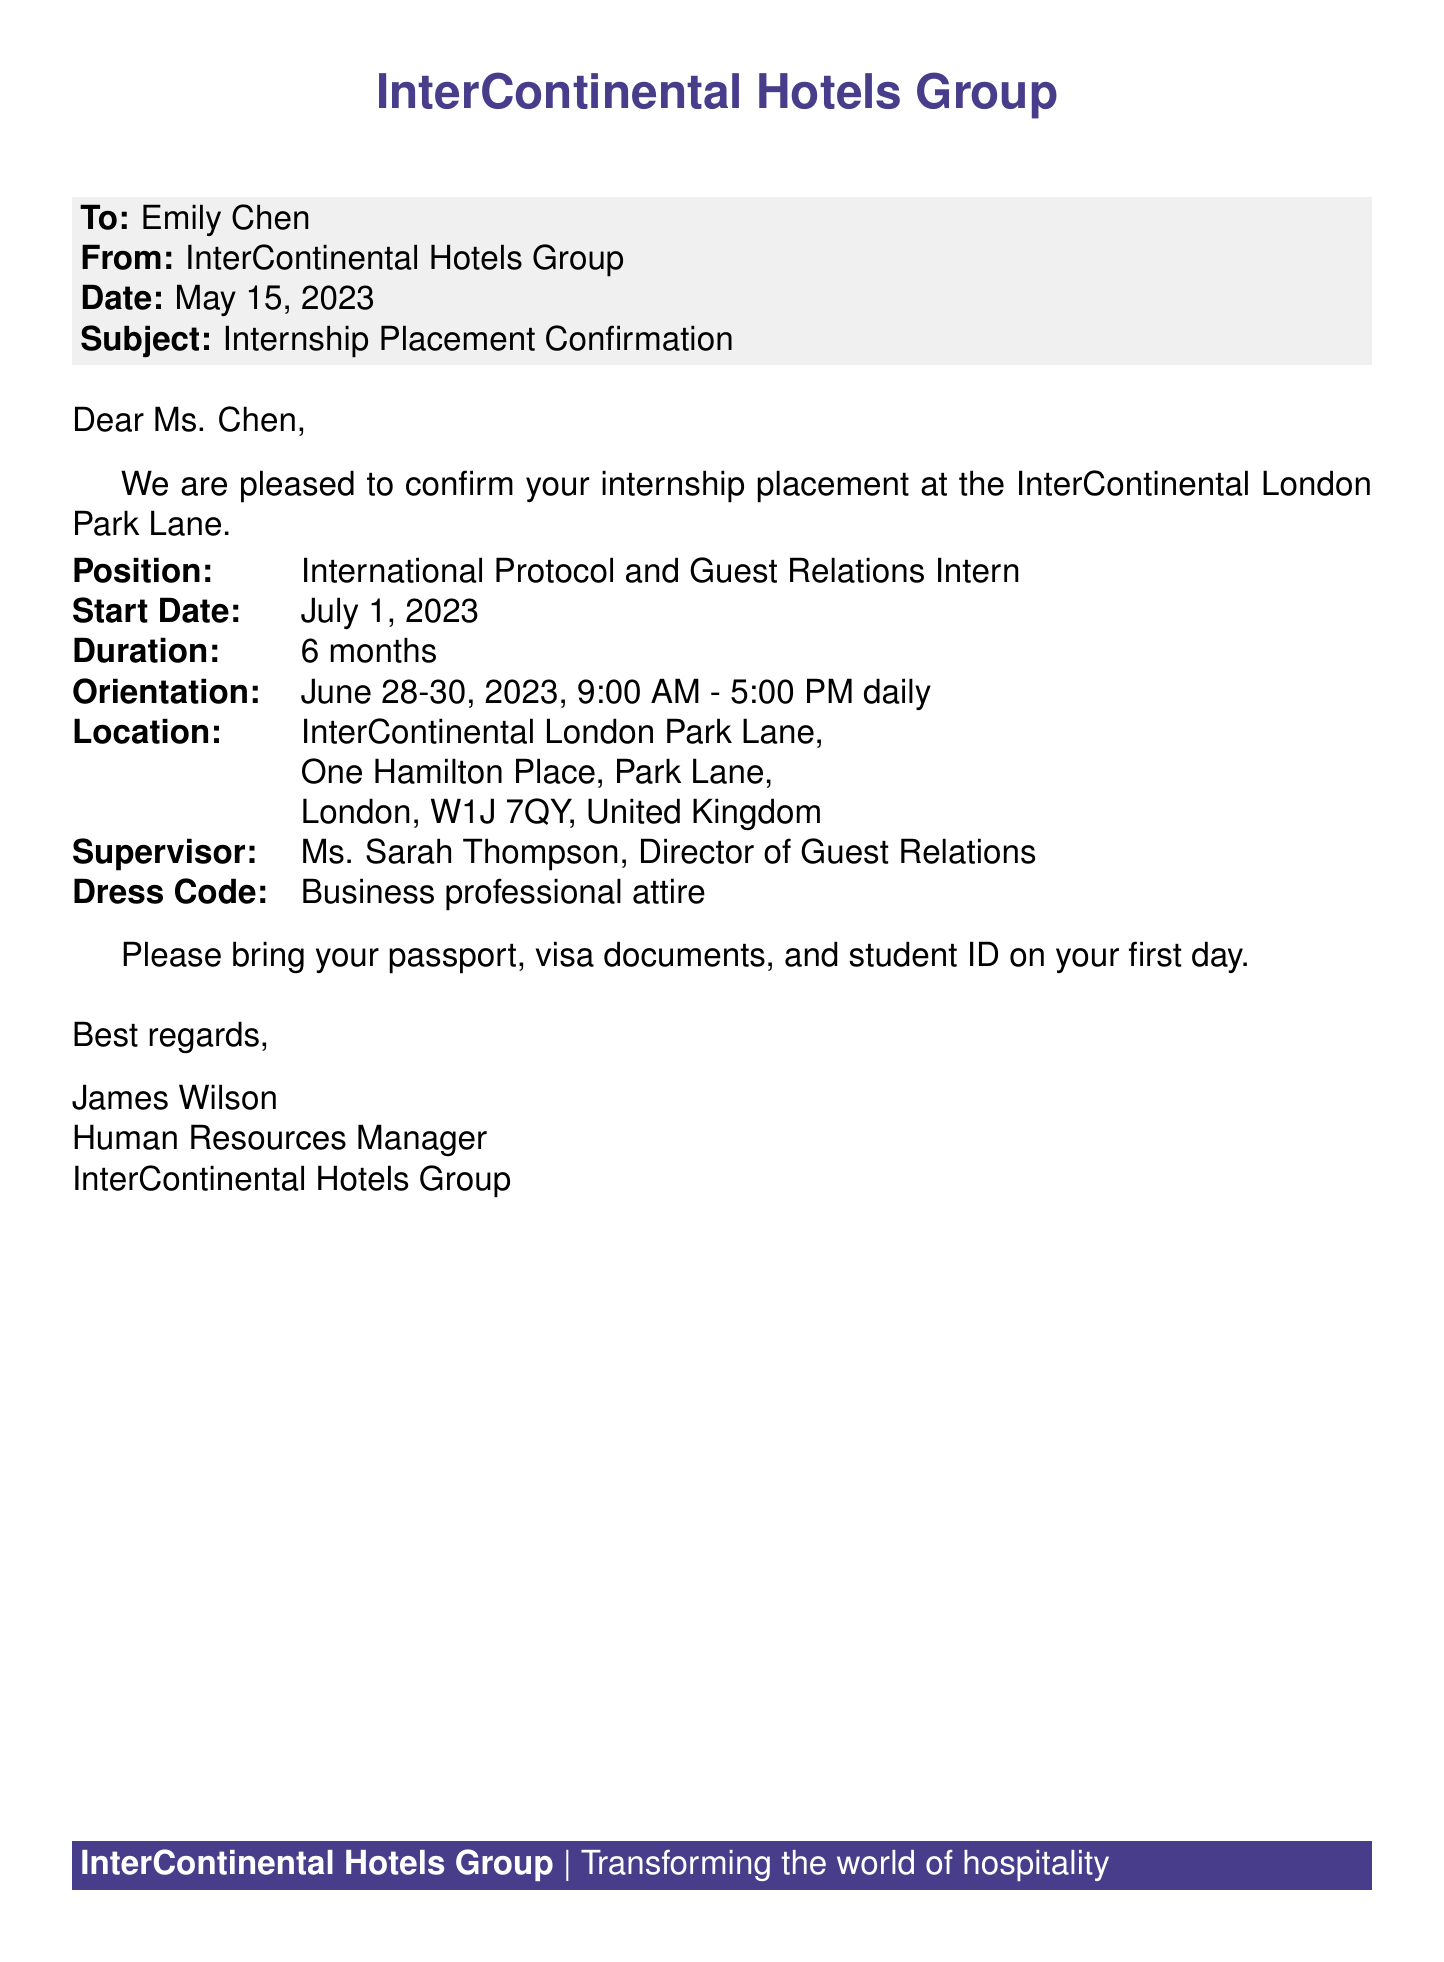What is the name of the hotel? The document states the name of the hotel as InterContinental London Park Lane.
Answer: InterContinental London Park Lane What is the internship start date? The start date of the internship is specified as July 1, 2023.
Answer: July 1, 2023 Who is the supervisor for the internship? The document mentions Ms. Sarah Thompson as the supervisor.
Answer: Ms. Sarah Thompson What is the duration of the internship? The duration of the internship is indicated to be 6 months.
Answer: 6 months When is the orientation scheduled? The orientation dates are provided as June 28-30, 2023.
Answer: June 28-30, 2023 What is the dress code for the internship? The document specifies the dress code as business professional attire.
Answer: Business professional attire What documents should be brought on the first day? The fax instructs to bring a passport, visa documents, and student ID.
Answer: Passport, visa documents, and student ID What is the position title for the internship? The position title mentioned is International Protocol and Guest Relations Intern.
Answer: International Protocol and Guest Relations Intern 